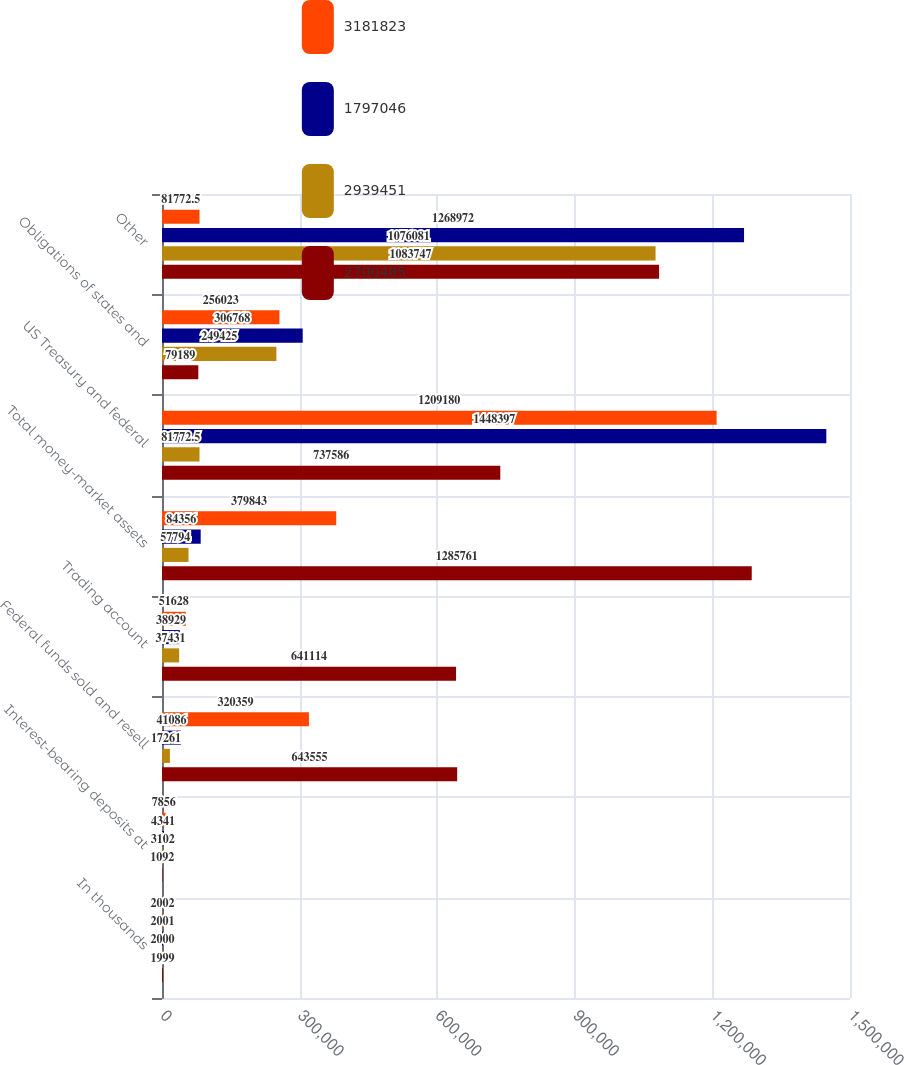Convert chart to OTSL. <chart><loc_0><loc_0><loc_500><loc_500><stacked_bar_chart><ecel><fcel>In thousands<fcel>Interest-bearing deposits at<fcel>Federal funds sold and resell<fcel>Trading account<fcel>Total money-market assets<fcel>US Treasury and federal<fcel>Obligations of states and<fcel>Other<nl><fcel>3.18182e+06<fcel>2002<fcel>7856<fcel>320359<fcel>51628<fcel>379843<fcel>1.20918e+06<fcel>256023<fcel>81772.5<nl><fcel>1.79705e+06<fcel>2001<fcel>4341<fcel>41086<fcel>38929<fcel>84356<fcel>1.4484e+06<fcel>306768<fcel>1.26897e+06<nl><fcel>2.93945e+06<fcel>2000<fcel>3102<fcel>17261<fcel>37431<fcel>57794<fcel>81772.5<fcel>249425<fcel>1.07608e+06<nl><fcel>2.70048e+06<fcel>1999<fcel>1092<fcel>643555<fcel>641114<fcel>1.28576e+06<fcel>737586<fcel>79189<fcel>1.08375e+06<nl></chart> 